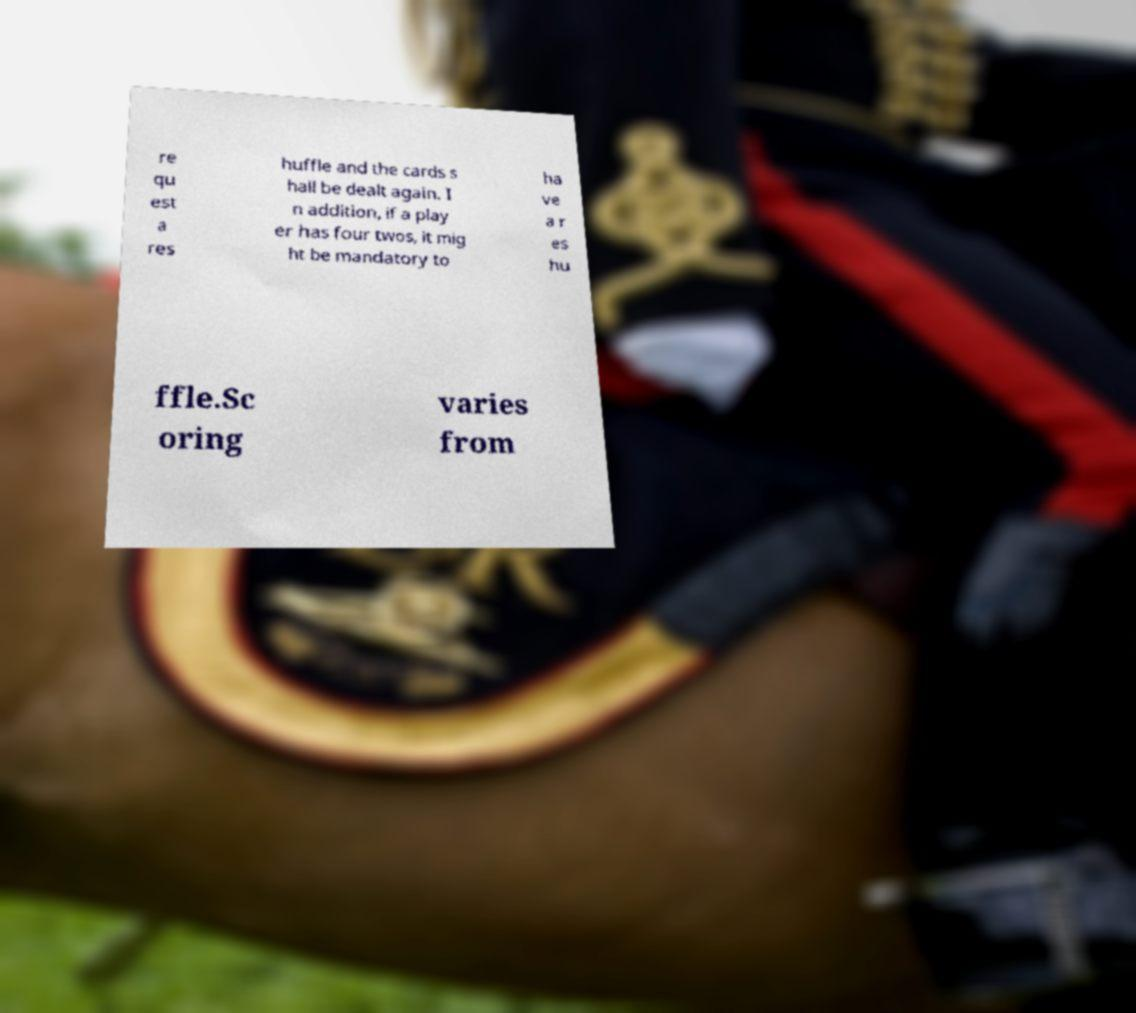There's text embedded in this image that I need extracted. Can you transcribe it verbatim? re qu est a res huffle and the cards s hall be dealt again. I n addition, if a play er has four twos, it mig ht be mandatory to ha ve a r es hu ffle.Sc oring varies from 